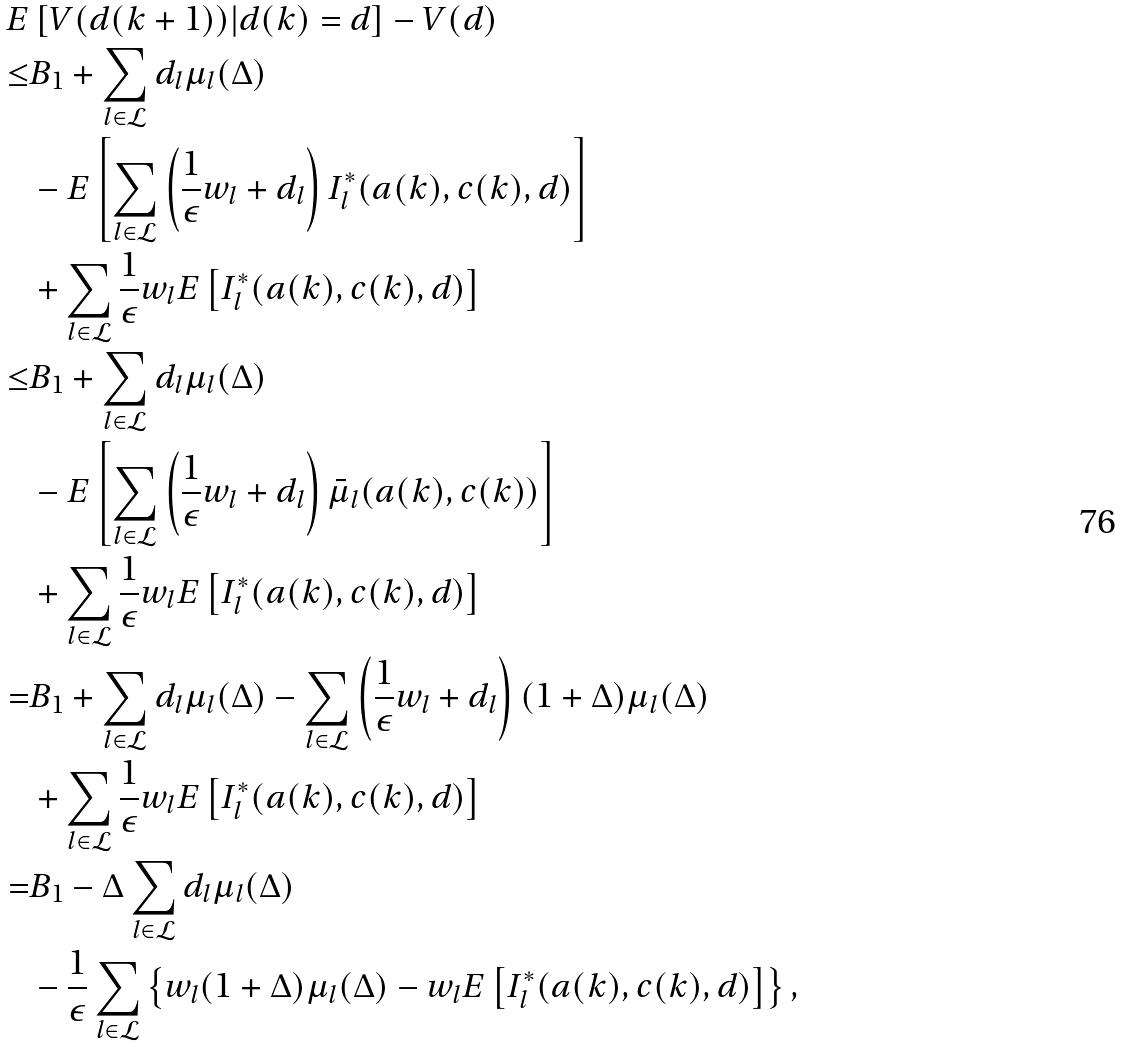Convert formula to latex. <formula><loc_0><loc_0><loc_500><loc_500>E & \left [ V ( d ( k + 1 ) ) | d ( k ) = d \right ] - V ( d ) \\ \leq & B _ { 1 } + \sum _ { l \in \mathcal { L } } d _ { l } \mu _ { l } ( \Delta ) \\ & - E \left [ \sum _ { l \in \mathcal { L } } \left ( \frac { 1 } { \epsilon } w _ { l } + d _ { l } \right ) I _ { l } ^ { * } ( a ( k ) , c ( k ) , d ) \right ] \\ & + \sum _ { l \in \mathcal { L } } \frac { 1 } { \epsilon } w _ { l } E \left [ I _ { l } ^ { * } ( a ( k ) , c ( k ) , d ) \right ] \\ \leq & B _ { 1 } + \sum _ { l \in \mathcal { L } } d _ { l } \mu _ { l } ( \Delta ) \\ & - E \left [ \sum _ { l \in \mathcal { L } } \left ( \frac { 1 } { \epsilon } w _ { l } + d _ { l } \right ) \bar { \mu } _ { l } ( a ( k ) , c ( k ) ) \right ] \\ & + \sum _ { l \in \mathcal { L } } \frac { 1 } { \epsilon } w _ { l } E \left [ I _ { l } ^ { * } ( a ( k ) , c ( k ) , d ) \right ] \\ = & B _ { 1 } + \sum _ { l \in \mathcal { L } } d _ { l } \mu _ { l } ( \Delta ) - \sum _ { l \in \mathcal { L } } \left ( \frac { 1 } { \epsilon } w _ { l } + d _ { l } \right ) ( 1 + \Delta ) \mu _ { l } ( \Delta ) \\ & + \sum _ { l \in \mathcal { L } } \frac { 1 } { \epsilon } w _ { l } E \left [ I _ { l } ^ { * } ( a ( k ) , c ( k ) , d ) \right ] \\ = & B _ { 1 } - \Delta \sum _ { l \in \mathcal { L } } d _ { l } \mu _ { l } ( \Delta ) \\ & - \frac { 1 } { \epsilon } \sum _ { l \in \mathcal { L } } \left \{ w _ { l } ( 1 + \Delta ) \mu _ { l } ( \Delta ) - w _ { l } E \left [ I _ { l } ^ { * } ( a ( k ) , c ( k ) , d ) \right ] \right \} ,</formula> 